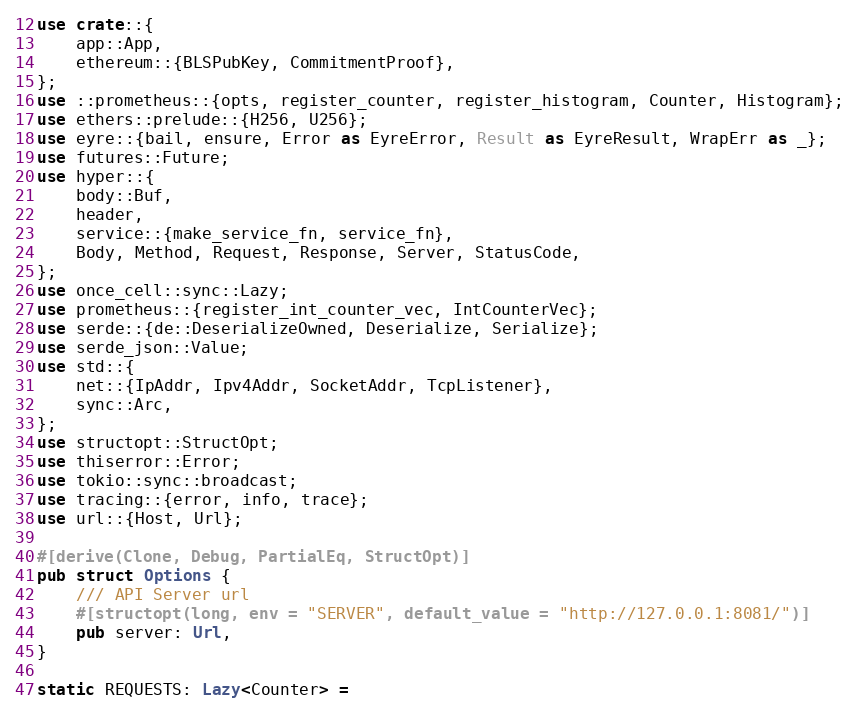Convert code to text. <code><loc_0><loc_0><loc_500><loc_500><_Rust_>use crate::{
    app::App,
    ethereum::{BLSPubKey, CommitmentProof},
};
use ::prometheus::{opts, register_counter, register_histogram, Counter, Histogram};
use ethers::prelude::{H256, U256};
use eyre::{bail, ensure, Error as EyreError, Result as EyreResult, WrapErr as _};
use futures::Future;
use hyper::{
    body::Buf,
    header,
    service::{make_service_fn, service_fn},
    Body, Method, Request, Response, Server, StatusCode,
};
use once_cell::sync::Lazy;
use prometheus::{register_int_counter_vec, IntCounterVec};
use serde::{de::DeserializeOwned, Deserialize, Serialize};
use serde_json::Value;
use std::{
    net::{IpAddr, Ipv4Addr, SocketAddr, TcpListener},
    sync::Arc,
};
use structopt::StructOpt;
use thiserror::Error;
use tokio::sync::broadcast;
use tracing::{error, info, trace};
use url::{Host, Url};

#[derive(Clone, Debug, PartialEq, StructOpt)]
pub struct Options {
    /// API Server url
    #[structopt(long, env = "SERVER", default_value = "http://127.0.0.1:8081/")]
    pub server: Url,
}

static REQUESTS: Lazy<Counter> =</code> 